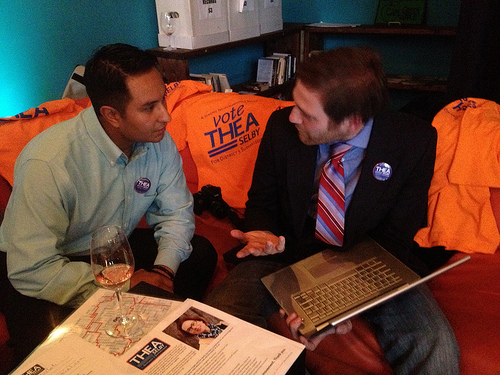<image>
Is the shirt behind the man? Yes. From this viewpoint, the shirt is positioned behind the man, with the man partially or fully occluding the shirt. Is there a tie next to the button? No. The tie is not positioned next to the button. They are located in different areas of the scene. 